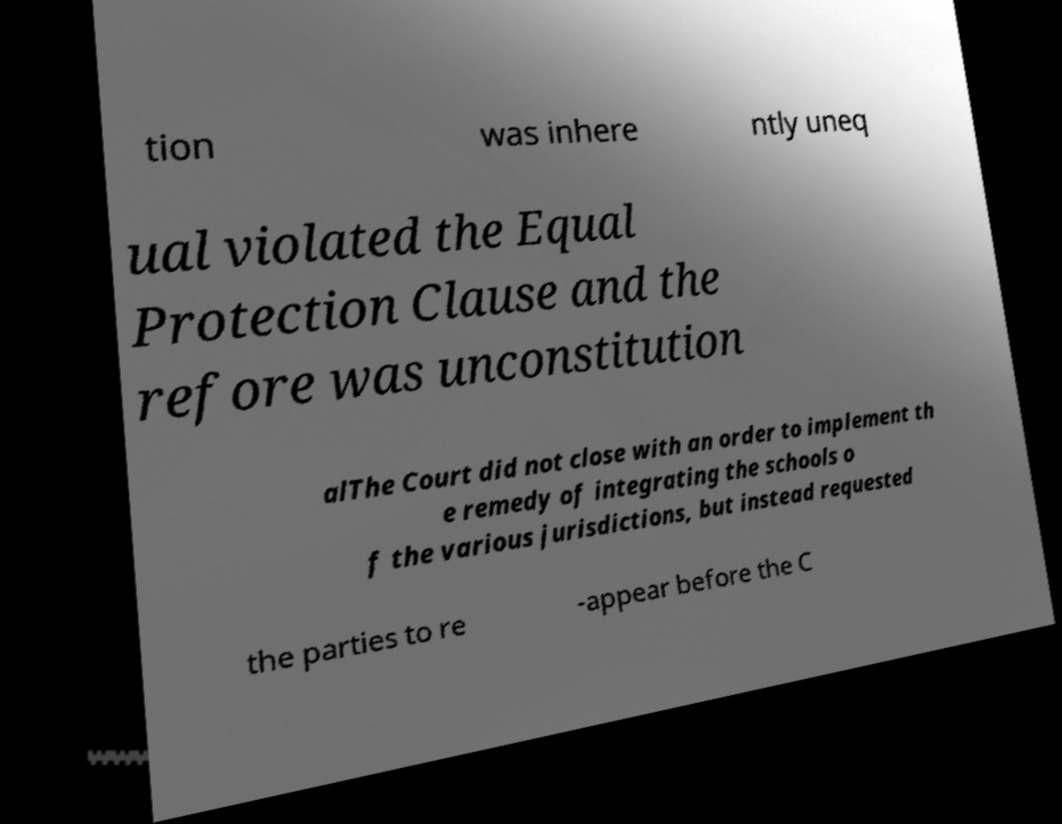Please identify and transcribe the text found in this image. tion was inhere ntly uneq ual violated the Equal Protection Clause and the refore was unconstitution alThe Court did not close with an order to implement th e remedy of integrating the schools o f the various jurisdictions, but instead requested the parties to re -appear before the C 